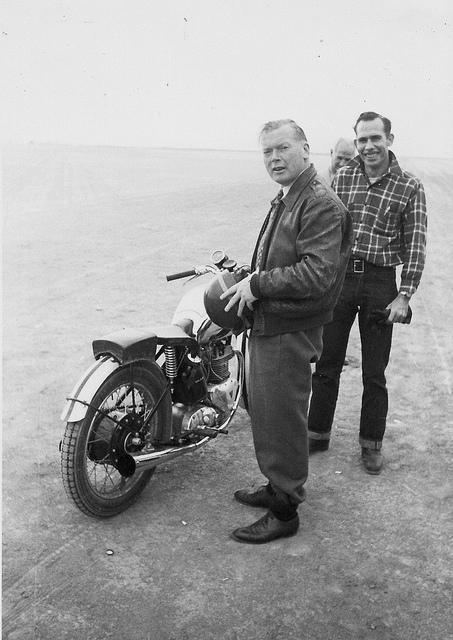How many people are visible?
Give a very brief answer. 2. 